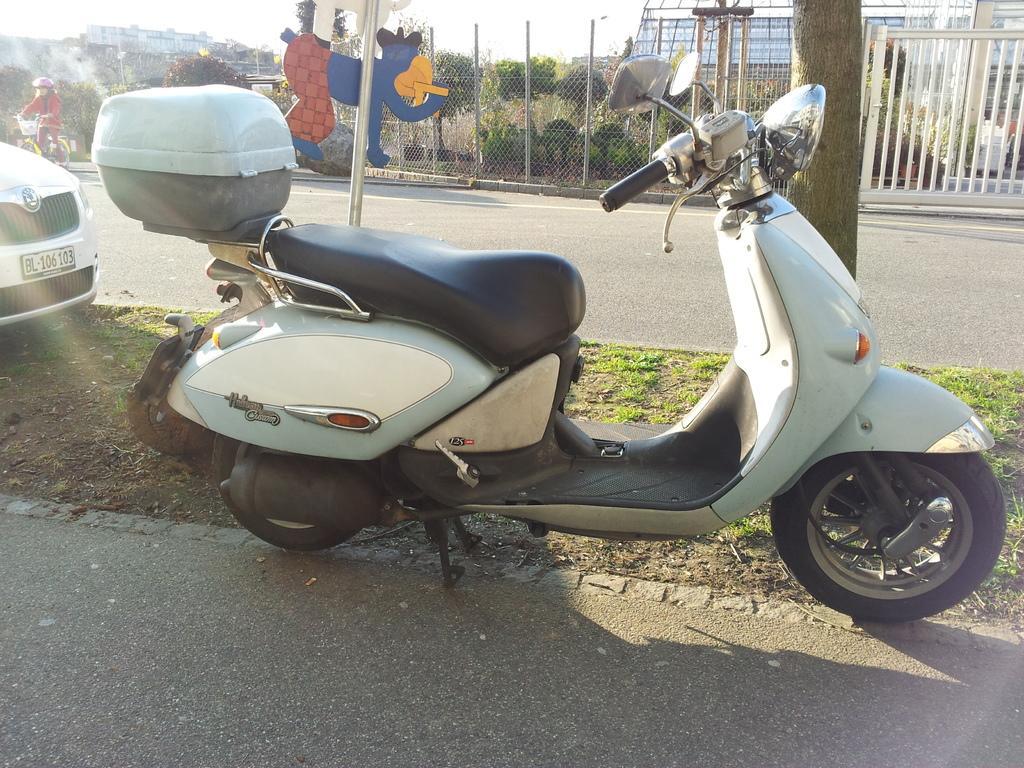Can you describe this image briefly? In the center of the image we can see a scooter. On the left there is a car. At the bottom we can see a road. In the background there are poles, trees, mesh, gate and buildings. On the left there is a girl riding a bicycle. 